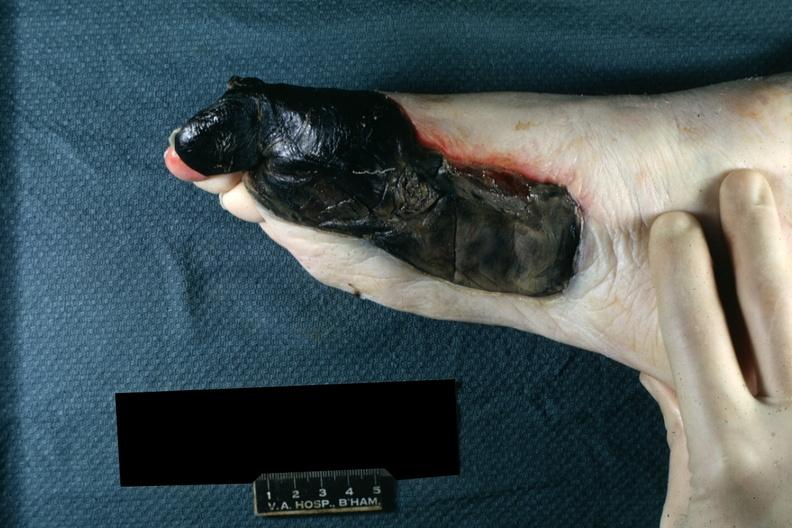what left foot?
Answer the question using a single word or phrase. Medial aspect 